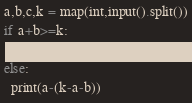<code> <loc_0><loc_0><loc_500><loc_500><_Python_>a,b,c,k = map(int,input().split())
if a+b>=k:
  print(a)
else:
  print(a-(k-a-b))</code> 